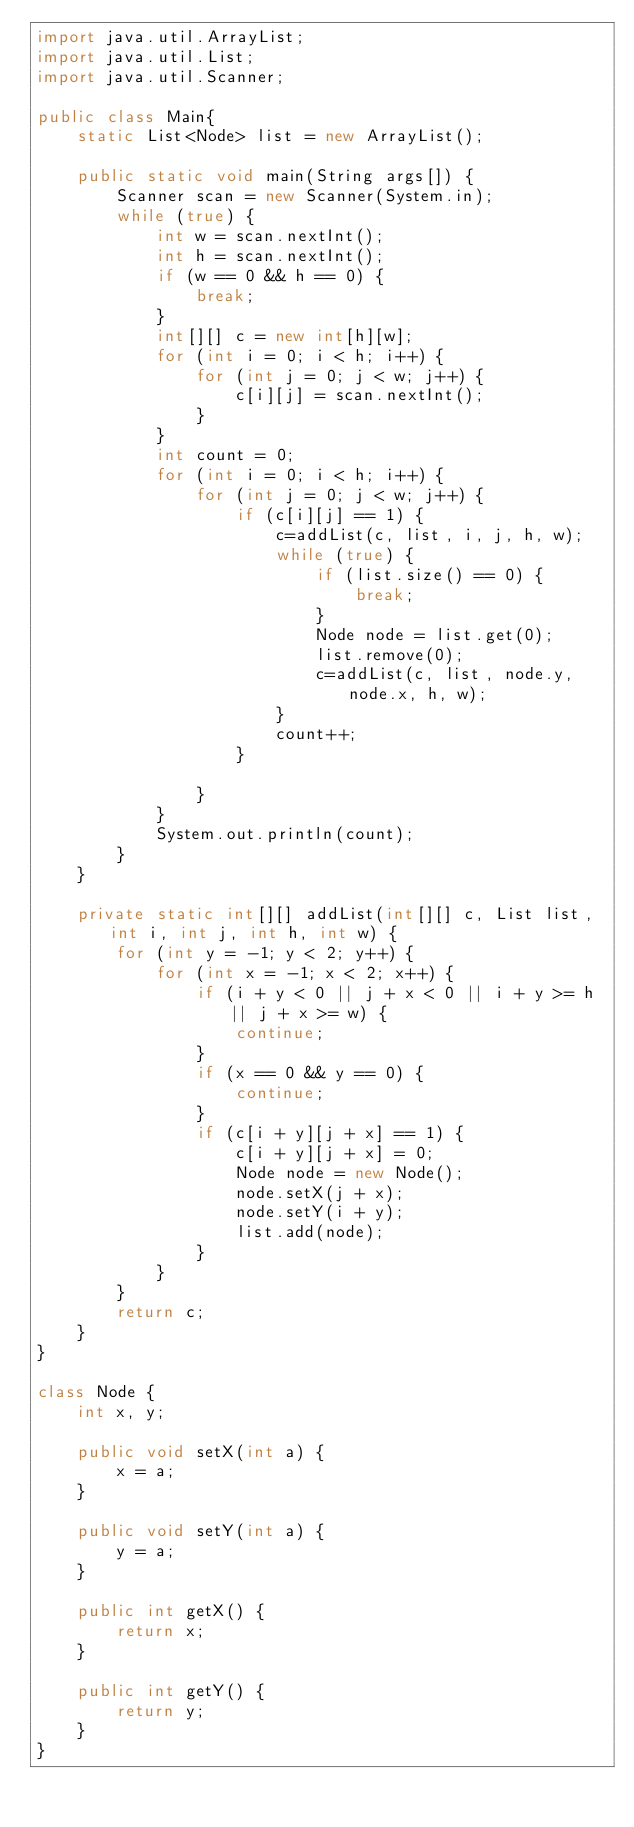<code> <loc_0><loc_0><loc_500><loc_500><_Java_>import java.util.ArrayList;
import java.util.List;
import java.util.Scanner;

public class Main{
    static List<Node> list = new ArrayList();

    public static void main(String args[]) {
        Scanner scan = new Scanner(System.in);
        while (true) {
            int w = scan.nextInt();
            int h = scan.nextInt();
            if (w == 0 && h == 0) {
                break;
            }
            int[][] c = new int[h][w];
            for (int i = 0; i < h; i++) {
                for (int j = 0; j < w; j++) {
                    c[i][j] = scan.nextInt();
                }
            }
            int count = 0;
            for (int i = 0; i < h; i++) {
                for (int j = 0; j < w; j++) {
                    if (c[i][j] == 1) {
                        c=addList(c, list, i, j, h, w);
                        while (true) {
                            if (list.size() == 0) {
                                break;
                            }
                            Node node = list.get(0);
                            list.remove(0);
                            c=addList(c, list, node.y, node.x, h, w);
                        }
                        count++;
                    }

                }
            }
            System.out.println(count);
        }
    }

    private static int[][] addList(int[][] c, List list, int i, int j, int h, int w) {
        for (int y = -1; y < 2; y++) {
            for (int x = -1; x < 2; x++) {
                if (i + y < 0 || j + x < 0 || i + y >= h || j + x >= w) {
                    continue;
                }
                if (x == 0 && y == 0) {
                    continue;
                }
                if (c[i + y][j + x] == 1) {
                    c[i + y][j + x] = 0;
                    Node node = new Node();
                    node.setX(j + x);
                    node.setY(i + y);
                    list.add(node);
                }
            }
        }
        return c;
    }
}

class Node {
    int x, y;

    public void setX(int a) {
        x = a;
    }

    public void setY(int a) {
        y = a;
    }

    public int getX() {
        return x;
    }

    public int getY() {
        return y;
    }
}
</code> 